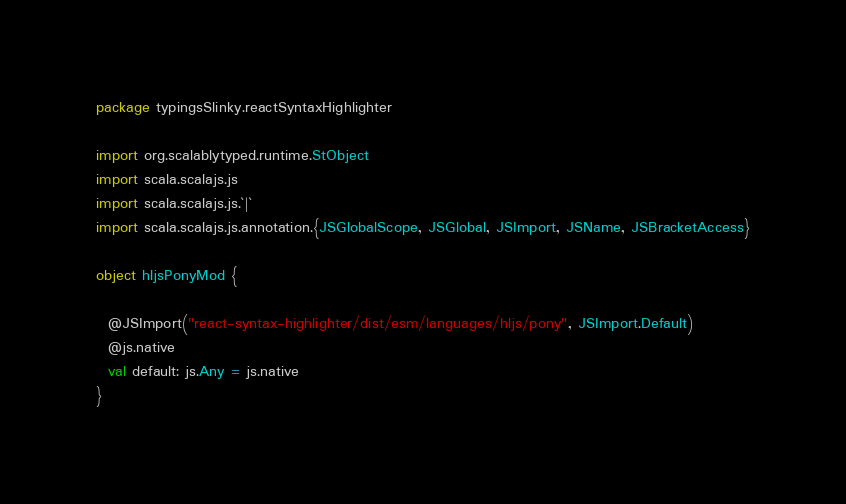Convert code to text. <code><loc_0><loc_0><loc_500><loc_500><_Scala_>package typingsSlinky.reactSyntaxHighlighter

import org.scalablytyped.runtime.StObject
import scala.scalajs.js
import scala.scalajs.js.`|`
import scala.scalajs.js.annotation.{JSGlobalScope, JSGlobal, JSImport, JSName, JSBracketAccess}

object hljsPonyMod {
  
  @JSImport("react-syntax-highlighter/dist/esm/languages/hljs/pony", JSImport.Default)
  @js.native
  val default: js.Any = js.native
}
</code> 